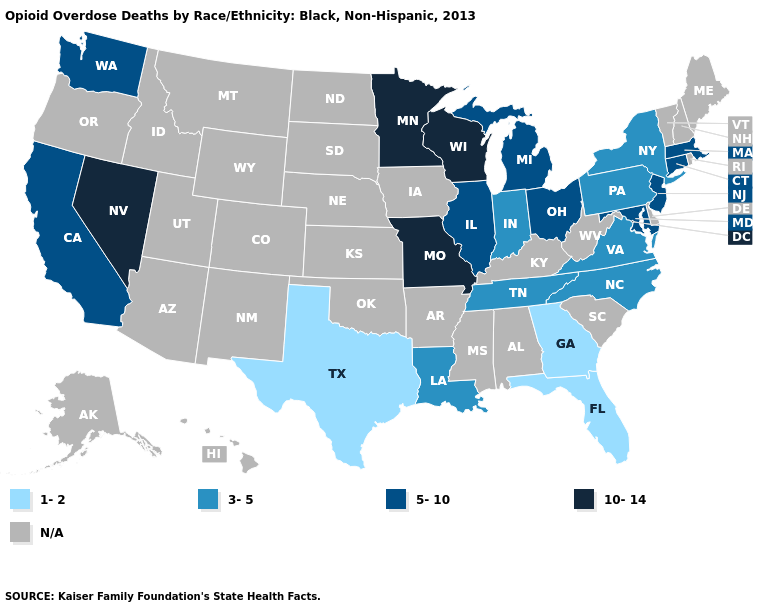What is the value of Nebraska?
Write a very short answer. N/A. How many symbols are there in the legend?
Give a very brief answer. 5. What is the value of Minnesota?
Keep it brief. 10-14. What is the lowest value in the USA?
Give a very brief answer. 1-2. Does Wisconsin have the highest value in the MidWest?
Quick response, please. Yes. Name the states that have a value in the range 1-2?
Keep it brief. Florida, Georgia, Texas. What is the lowest value in the MidWest?
Quick response, please. 3-5. What is the highest value in states that border Texas?
Quick response, please. 3-5. Does Missouri have the highest value in the USA?
Give a very brief answer. Yes. Name the states that have a value in the range 10-14?
Answer briefly. Minnesota, Missouri, Nevada, Wisconsin. Which states have the lowest value in the West?
Quick response, please. California, Washington. Name the states that have a value in the range 1-2?
Keep it brief. Florida, Georgia, Texas. Name the states that have a value in the range 10-14?
Keep it brief. Minnesota, Missouri, Nevada, Wisconsin. What is the value of Georgia?
Give a very brief answer. 1-2. Does Georgia have the lowest value in the USA?
Be succinct. Yes. 